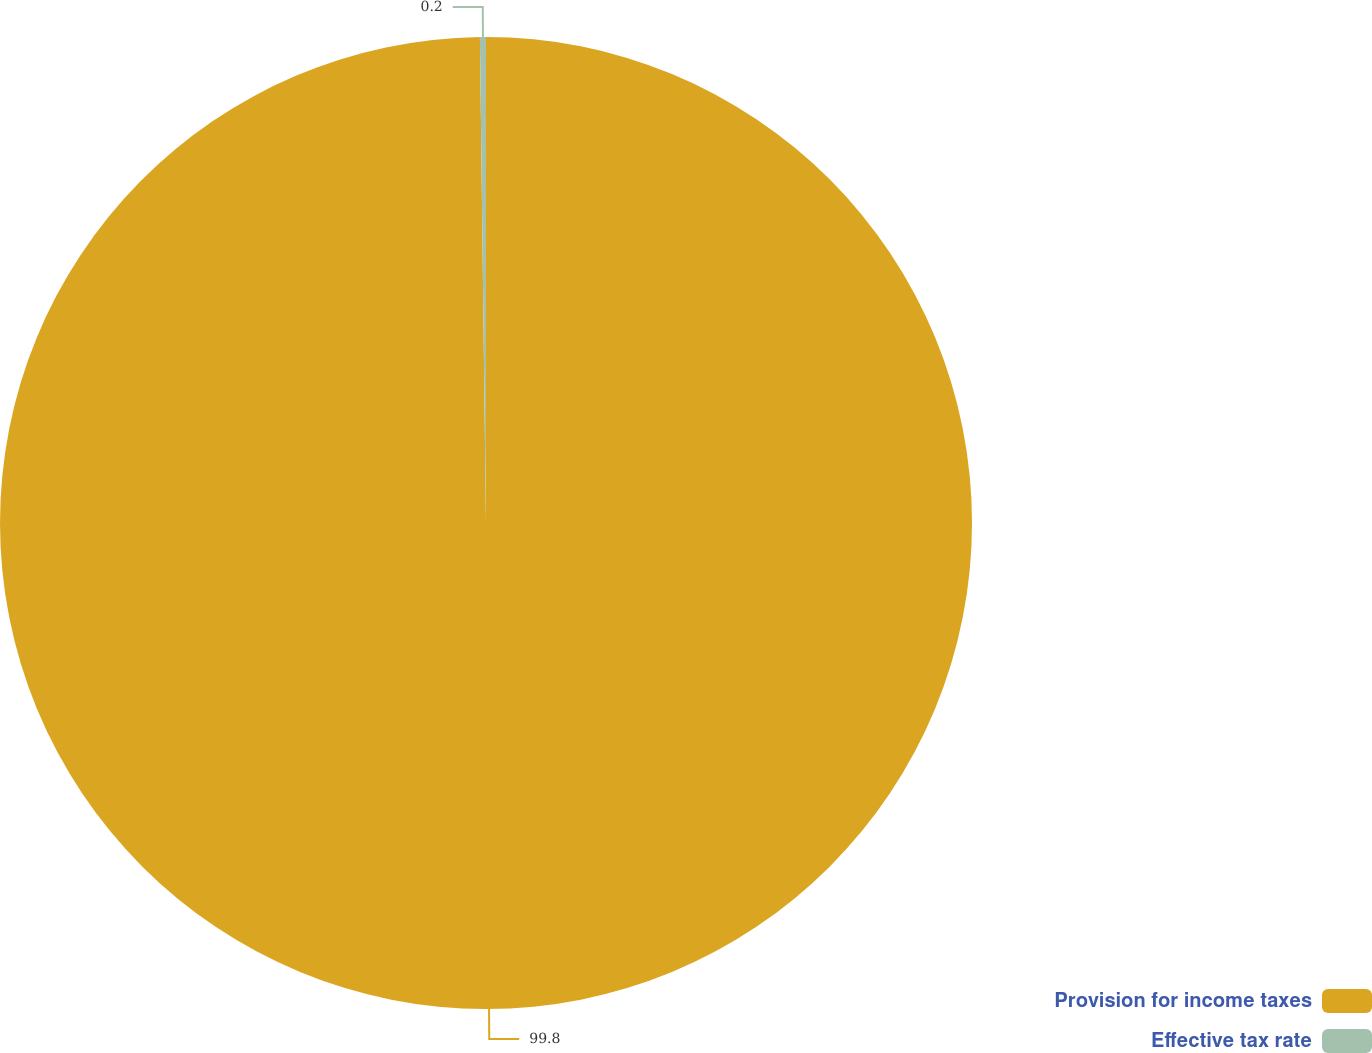Convert chart. <chart><loc_0><loc_0><loc_500><loc_500><pie_chart><fcel>Provision for income taxes<fcel>Effective tax rate<nl><fcel>99.8%<fcel>0.2%<nl></chart> 